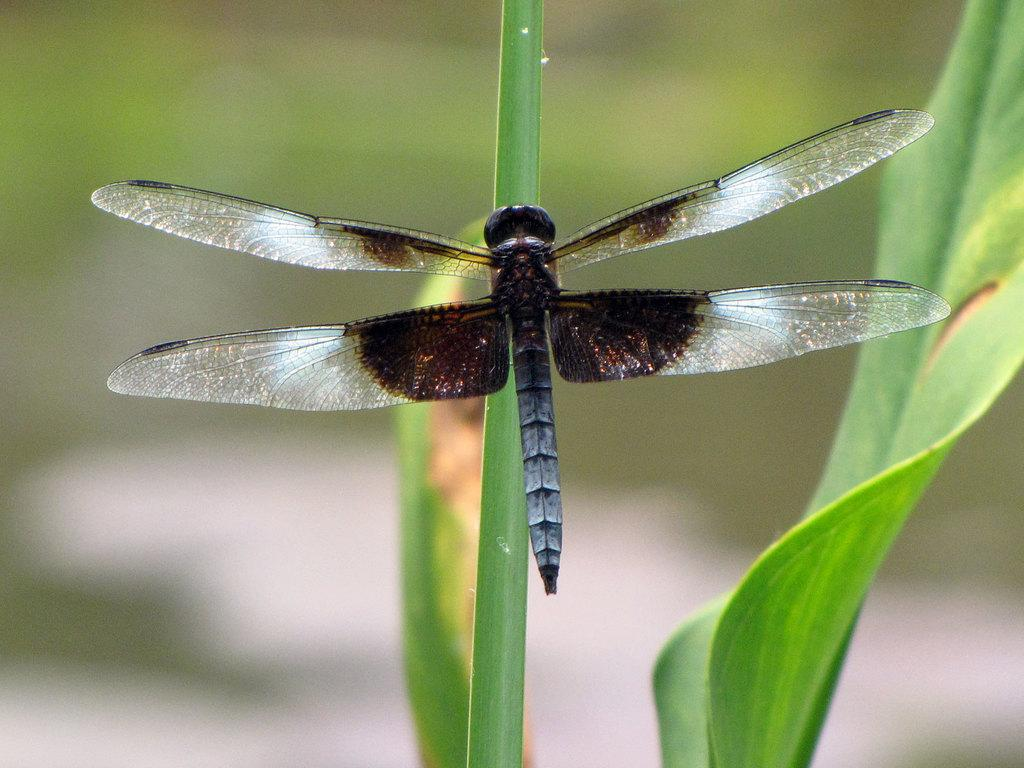What type of creature can be seen in the picture? There is an insect in the picture. Where is the insect located in the image? The insect is on a stem. What other elements are present in the picture besides the insect? Leaves are present in the picture. Can you describe the background of the image? The background of the image is blurry. How many girls are holding cherries in the image? There are no girls or cherries present in the image; it features an insect on a stem with leaves in the background. 